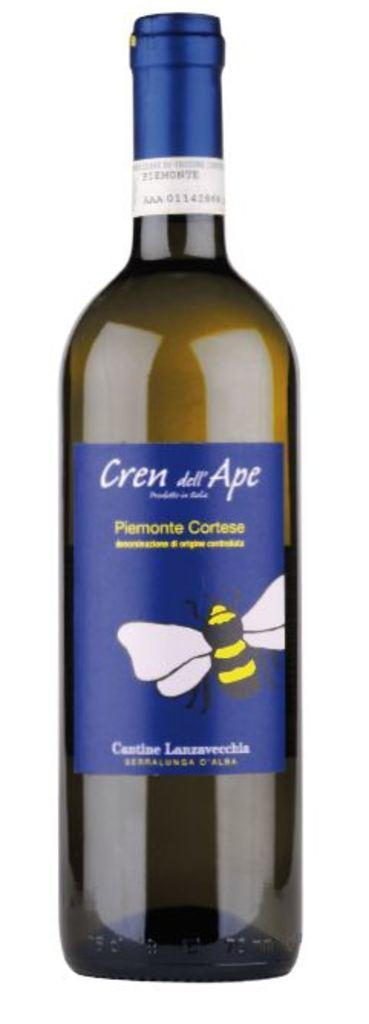Provide a one-sentence caption for the provided image. The blue label on the wine was richly colored. 